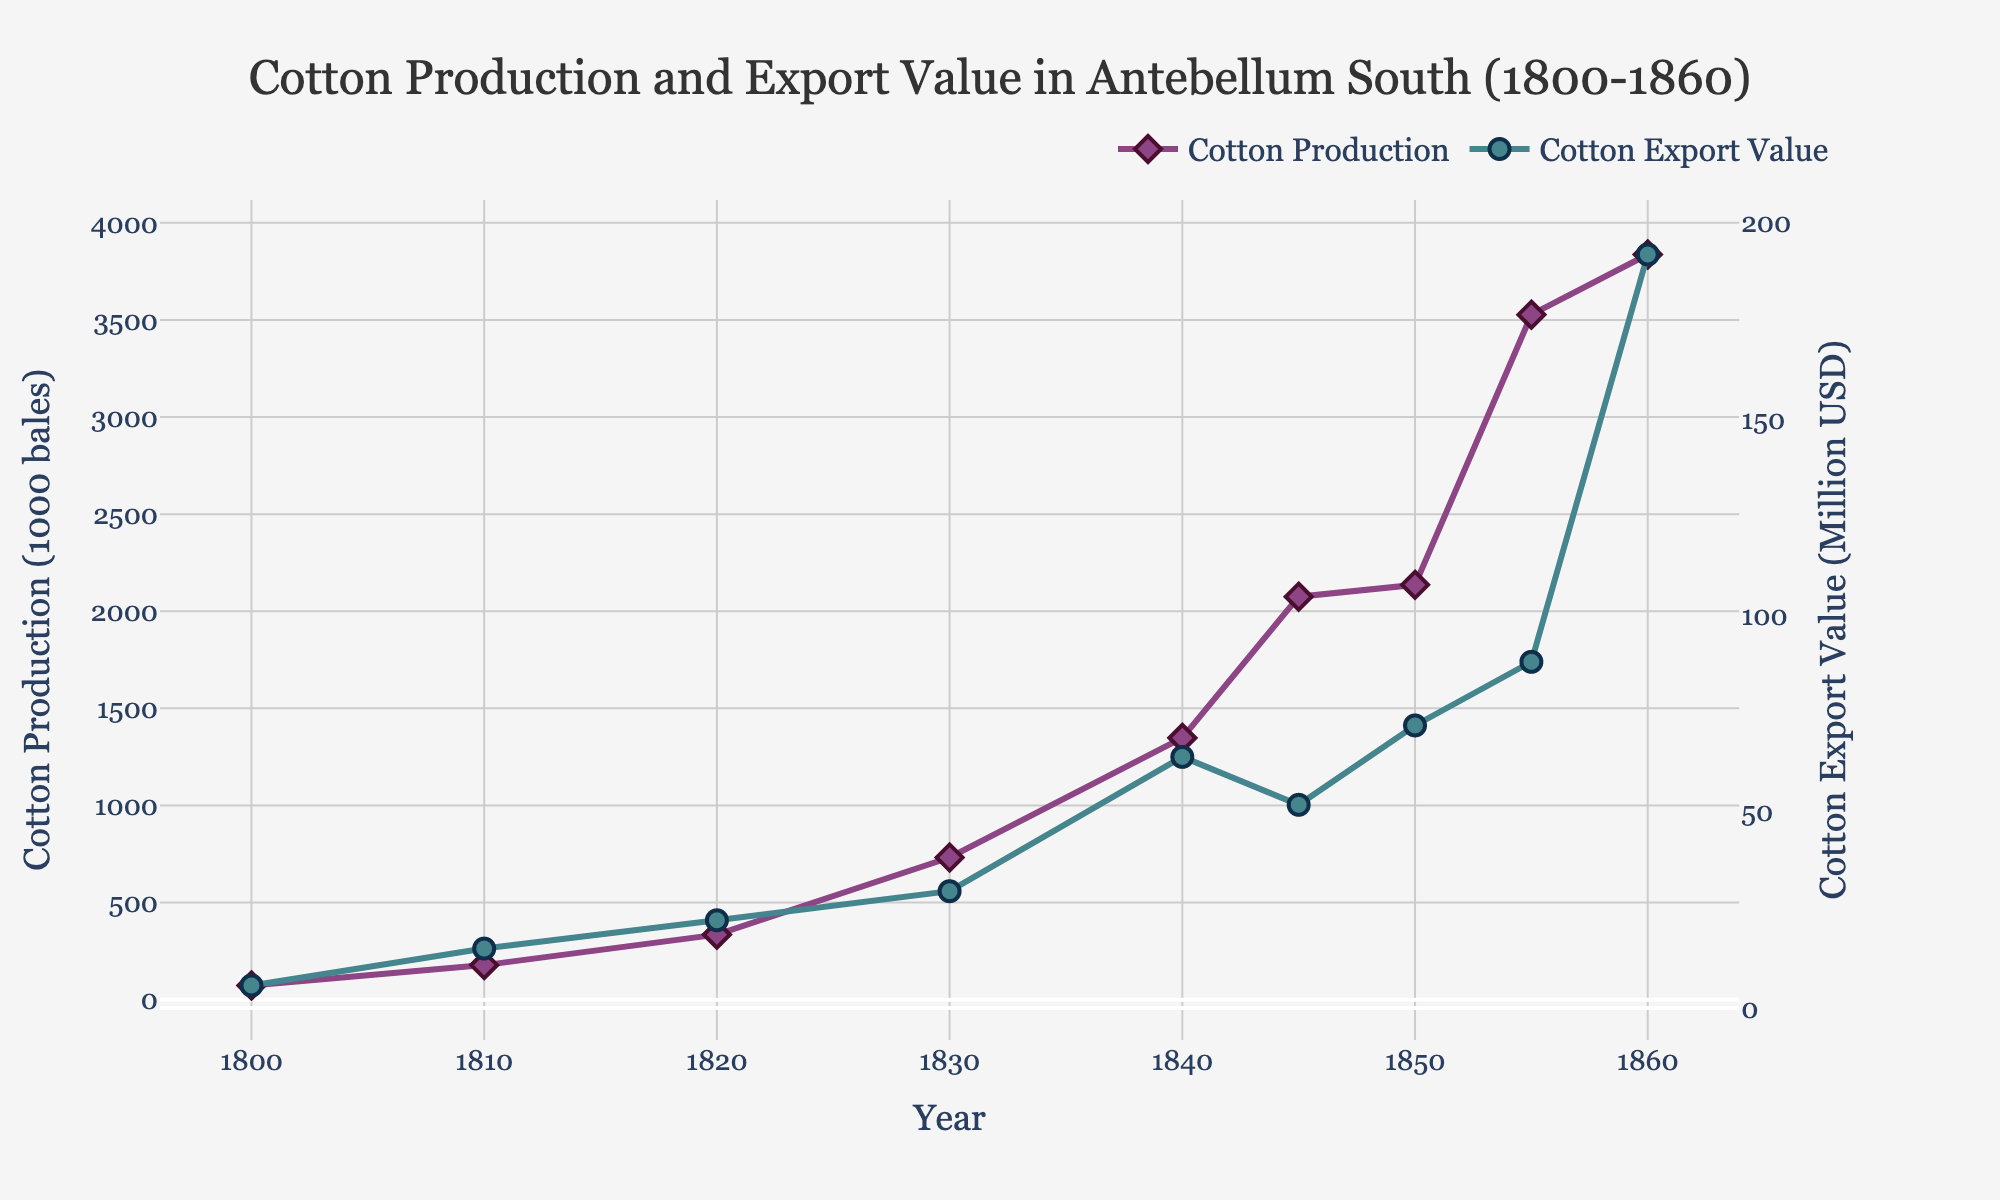What's the approximate difference in cotton production between 1850 and 1840? To find the difference in cotton production between 1850 and 1840, locate the values for these years. Cotton production in 1850 is 2136 (1000 bales), and in 1840, it's 1348 (1000 bales). Subtract the latter from the former: 2136 - 1348 = 788 (1000 bales).
Answer: 788 (1000 bales) During which period did the cotton export value experience the most significant increase? Analyze the export values for each year and identify the largest increase. The most significant jump is from 1855 to 1860, where the export value rises from 88.1 to 191.8 million USD, a difference of 191.8 - 88.1 = 103.7 million USD.
Answer: 1855 to 1860 In what year did cotton production surpass 2000 (1000 bales) for the first time? Look for the year in which cotton production first exceeds 2000 (1000 bales). Cotton production surpasses this mark between 1845 and 1850, with the production in 1845 being 2075 (1000 bales).
Answer: 1845 Identify the trend of cotton production from 1830 to 1845. To assess the trend, compare the values of cotton production in 1830 (732), 1840 (1348), and 1845 (2075). These values show a consistent and significant increase over time.
Answer: Increasing trend What is the ratio of cotton export value to cotton production in the year 1860? For 1860, the cotton production is 3837 (1000 bales), and the export value is 191.8 million USD. Calculate the ratio by dividing the export value by cotton production: 191.8 / 3837 = 0.05 (approximately).
Answer: 0.05 